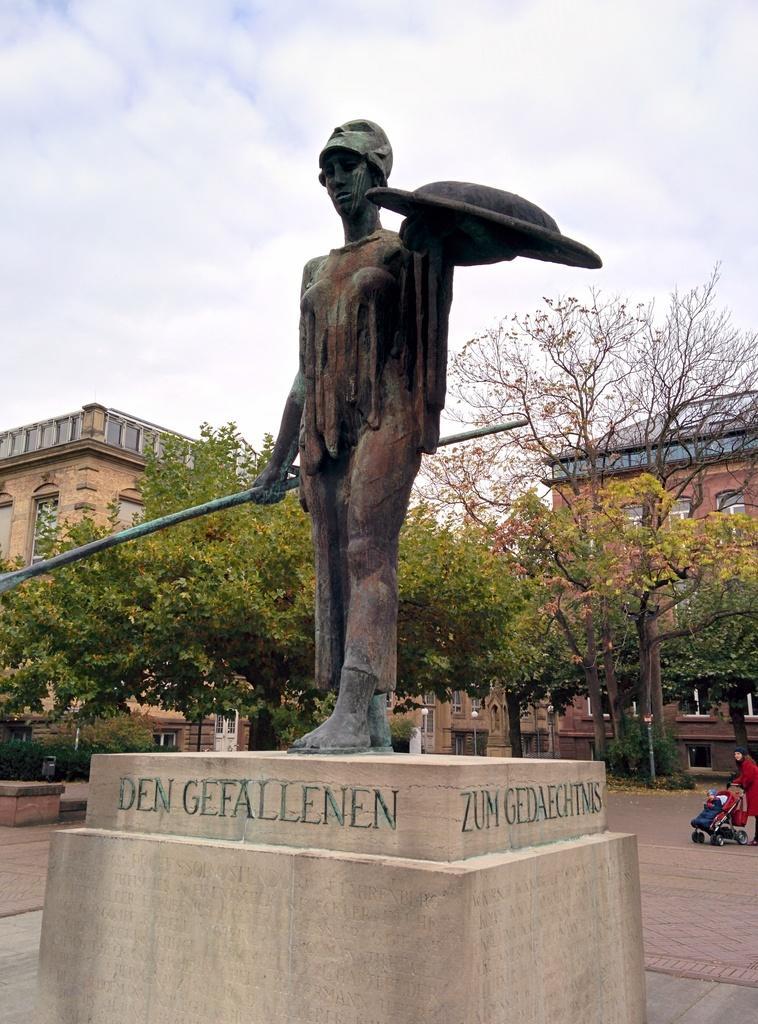How would you summarize this image in a sentence or two? In the middle it is a statue of a human behind it, there are trees, right side a woman is walking. She wore a red color dress. 